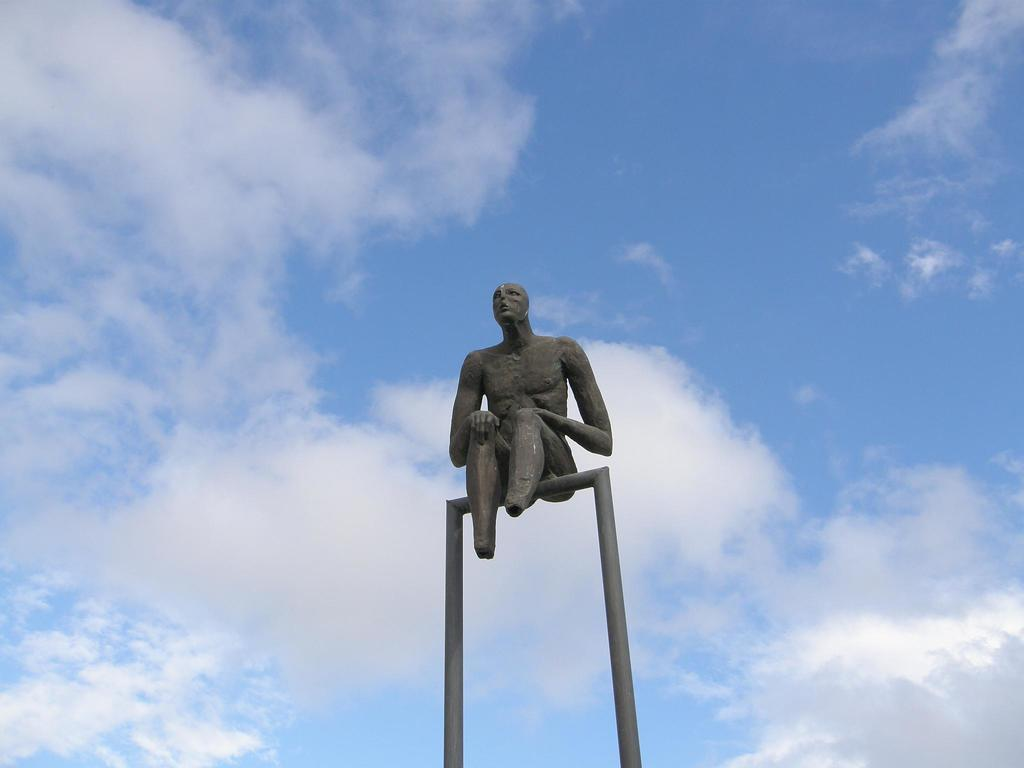What is the main subject of the image? There is a person sculpture in the image. What can be seen in the background of the image? The sky is visible in the image. What is the condition of the sky in the image? There are clouds in the sky. What type of frog can be seen feeling ashamed in the image? There is no frog present in the image, and therefore no such emotion can be observed. 